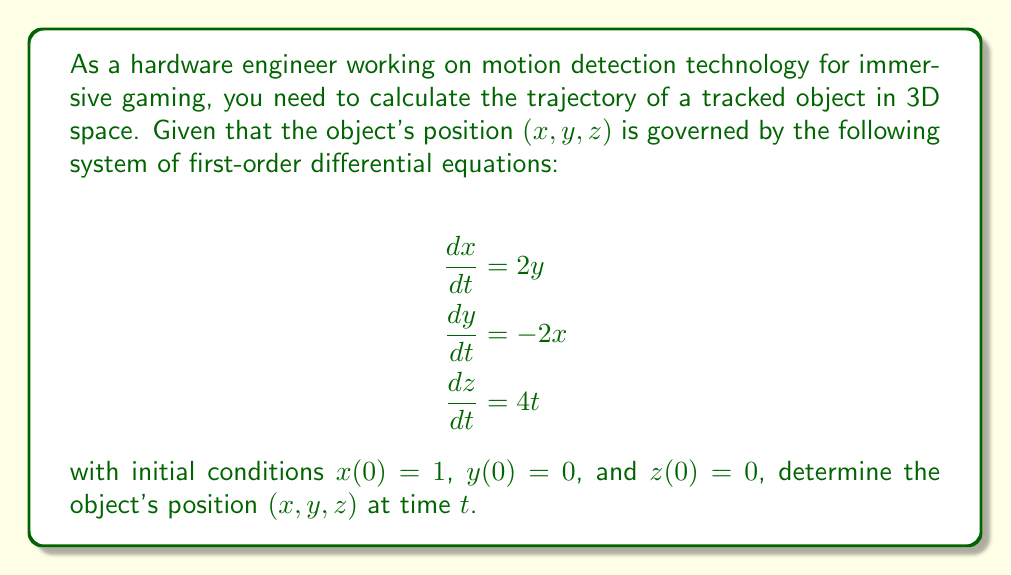Solve this math problem. To solve this system of differential equations, we'll approach each equation separately:

1. For $x$ and $y$:
   The equations for $x$ and $y$ form a coupled system:
   $$\begin{align}
   \frac{dx}{dt} &= 2y \\
   \frac{dy}{dt} &= -2x
   \end{align}$$
   
   This system represents simple harmonic motion. We can solve it by:
   a) Differentiating the first equation: $\frac{d^2x}{dt^2} = 2\frac{dy}{dt} = -4x$
   b) This gives us the second-order ODE: $\frac{d^2x}{dt^2} + 4x = 0$
   c) The general solution is: $x(t) = A\cos(2t) + B\sin(2t)$
   d) Using the initial condition $x(0) = 1$, we get $A = 1$ and $B = 0$
   e) Therefore, $x(t) = \cos(2t)$
   f) Substituting back into $\frac{dx}{dt} = 2y$, we get:
      $-2\sin(2t) = 2y$
      $y(t) = -\sin(2t)$

2. For $z$:
   The equation $\frac{dz}{dt} = 4t$ can be solved by direct integration:
   $$z(t) = \int 4t \, dt = 2t^2 + C$$
   Using the initial condition $z(0) = 0$, we get $C = 0$

Therefore, the complete solution is:
$$\begin{align}
x(t) &= \cos(2t) \\
y(t) &= -\sin(2t) \\
z(t) &= 2t^2
\end{align}$$
Answer: The object's position $(x, y, z)$ at time $t$ is given by:
$$(\cos(2t), -\sin(2t), 2t^2)$$ 